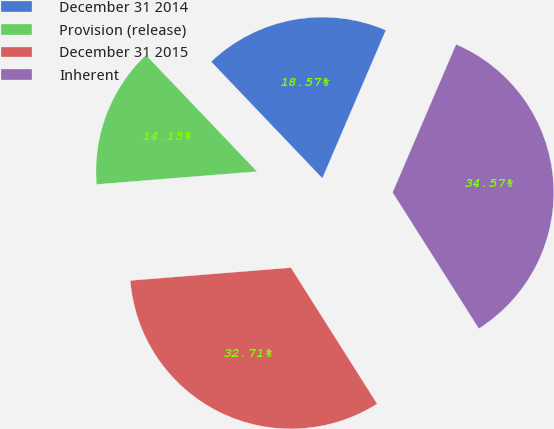Convert chart. <chart><loc_0><loc_0><loc_500><loc_500><pie_chart><fcel>December 31 2014<fcel>Provision (release)<fcel>December 31 2015<fcel>Inherent<nl><fcel>18.57%<fcel>14.15%<fcel>32.71%<fcel>34.57%<nl></chart> 